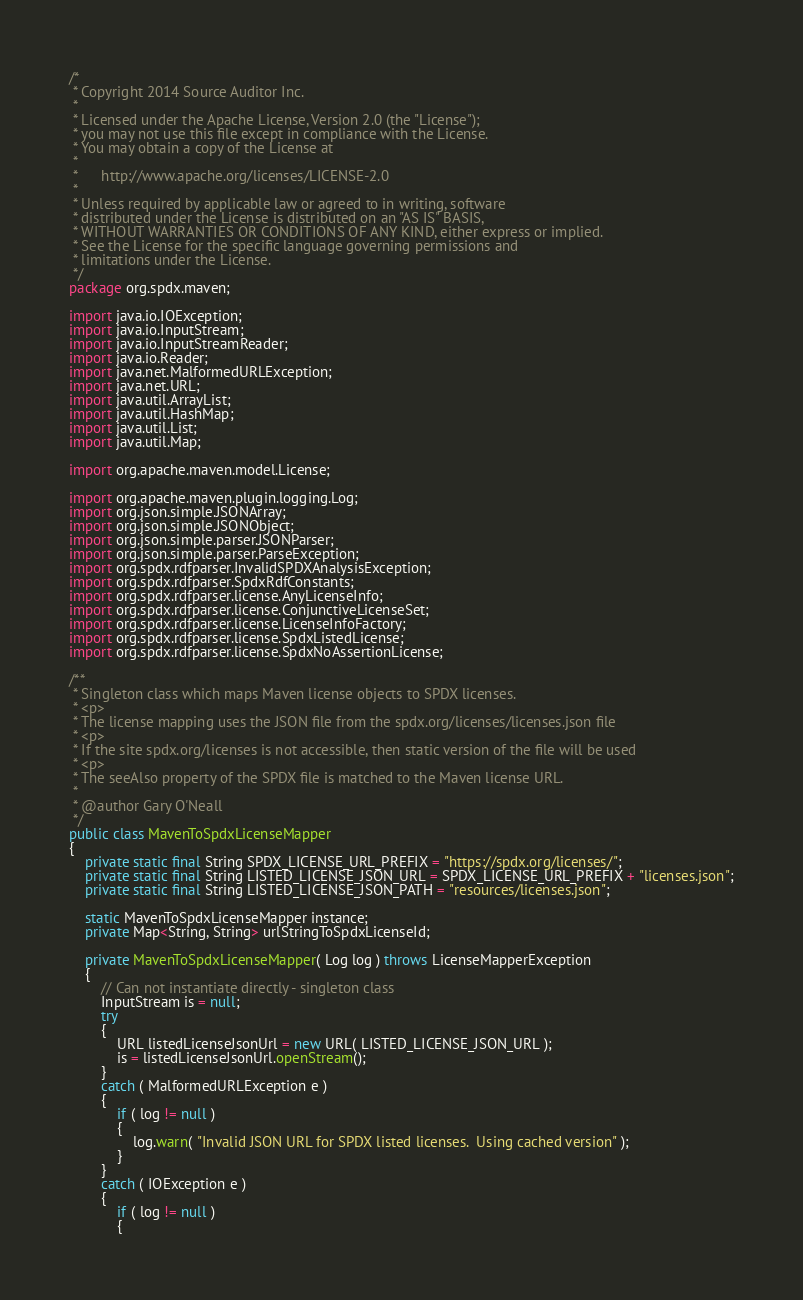Convert code to text. <code><loc_0><loc_0><loc_500><loc_500><_Java_>/*
 * Copyright 2014 Source Auditor Inc.
 *
 * Licensed under the Apache License, Version 2.0 (the "License");
 * you may not use this file except in compliance with the License.
 * You may obtain a copy of the License at
 *
 *      http://www.apache.org/licenses/LICENSE-2.0
 *
 * Unless required by applicable law or agreed to in writing, software
 * distributed under the License is distributed on an "AS IS" BASIS,
 * WITHOUT WARRANTIES OR CONDITIONS OF ANY KIND, either express or implied.
 * See the License for the specific language governing permissions and
 * limitations under the License.
 */
package org.spdx.maven;

import java.io.IOException;
import java.io.InputStream;
import java.io.InputStreamReader;
import java.io.Reader;
import java.net.MalformedURLException;
import java.net.URL;
import java.util.ArrayList;
import java.util.HashMap;
import java.util.List;
import java.util.Map;

import org.apache.maven.model.License;

import org.apache.maven.plugin.logging.Log;
import org.json.simple.JSONArray;
import org.json.simple.JSONObject;
import org.json.simple.parser.JSONParser;
import org.json.simple.parser.ParseException;
import org.spdx.rdfparser.InvalidSPDXAnalysisException;
import org.spdx.rdfparser.SpdxRdfConstants;
import org.spdx.rdfparser.license.AnyLicenseInfo;
import org.spdx.rdfparser.license.ConjunctiveLicenseSet;
import org.spdx.rdfparser.license.LicenseInfoFactory;
import org.spdx.rdfparser.license.SpdxListedLicense;
import org.spdx.rdfparser.license.SpdxNoAssertionLicense;

/**
 * Singleton class which maps Maven license objects to SPDX licenses.
 * <p>
 * The license mapping uses the JSON file from the spdx.org/licenses/licenses.json file
 * <p>
 * If the site spdx.org/licenses is not accessible, then static version of the file will be used
 * <p>
 * The seeAlso property of the SPDX file is matched to the Maven license URL.
 *
 * @author Gary O'Neall
 */
public class MavenToSpdxLicenseMapper
{
    private static final String SPDX_LICENSE_URL_PREFIX = "https://spdx.org/licenses/";
    private static final String LISTED_LICENSE_JSON_URL = SPDX_LICENSE_URL_PREFIX + "licenses.json";
    private static final String LISTED_LICENSE_JSON_PATH = "resources/licenses.json";

    static MavenToSpdxLicenseMapper instance;
    private Map<String, String> urlStringToSpdxLicenseId;

    private MavenToSpdxLicenseMapper( Log log ) throws LicenseMapperException
    {
        // Can not instantiate directly - singleton class
        InputStream is = null;
        try
        {
            URL listedLicenseJsonUrl = new URL( LISTED_LICENSE_JSON_URL );
            is = listedLicenseJsonUrl.openStream();
        }
        catch ( MalformedURLException e )
        {
            if ( log != null )
            {
                log.warn( "Invalid JSON URL for SPDX listed licenses.  Using cached version" );
            }
        }
        catch ( IOException e )
        {
            if ( log != null )
            {</code> 